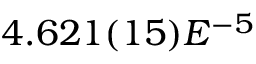Convert formula to latex. <formula><loc_0><loc_0><loc_500><loc_500>4 . 6 2 1 ( 1 5 ) E ^ { - 5 }</formula> 